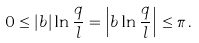<formula> <loc_0><loc_0><loc_500><loc_500>0 \leq | b | \ln \frac { q } { l } = \left | b \ln \frac { q } { l } \right | \leq \pi \, .</formula> 